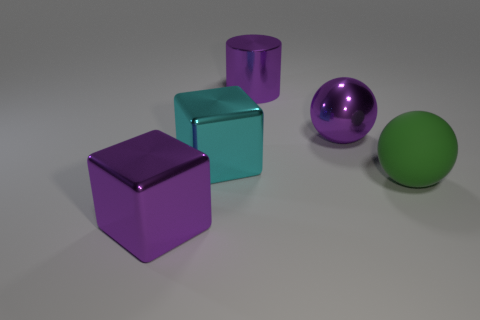The metal cylinder is what color?
Give a very brief answer. Purple. How many other objects are the same material as the big green sphere?
Give a very brief answer. 0. What number of purple things are either shiny things or metallic cylinders?
Provide a succinct answer. 3. There is a purple shiny thing in front of the big metal ball; does it have the same shape as the large cyan object that is on the left side of the big rubber ball?
Ensure brevity in your answer.  Yes. Do the large cylinder and the big sphere to the left of the large green matte object have the same color?
Provide a succinct answer. Yes. Is the color of the sphere in front of the purple metallic ball the same as the large metallic cylinder?
Offer a terse response. No. How many things are large purple things or purple objects that are right of the cyan metallic object?
Ensure brevity in your answer.  3. What is the material of the purple object that is both right of the purple metallic cube and on the left side of the large metal sphere?
Keep it short and to the point. Metal. What material is the big block behind the green matte object?
Provide a succinct answer. Metal. There is a ball that is the same material as the cylinder; what color is it?
Offer a very short reply. Purple. 